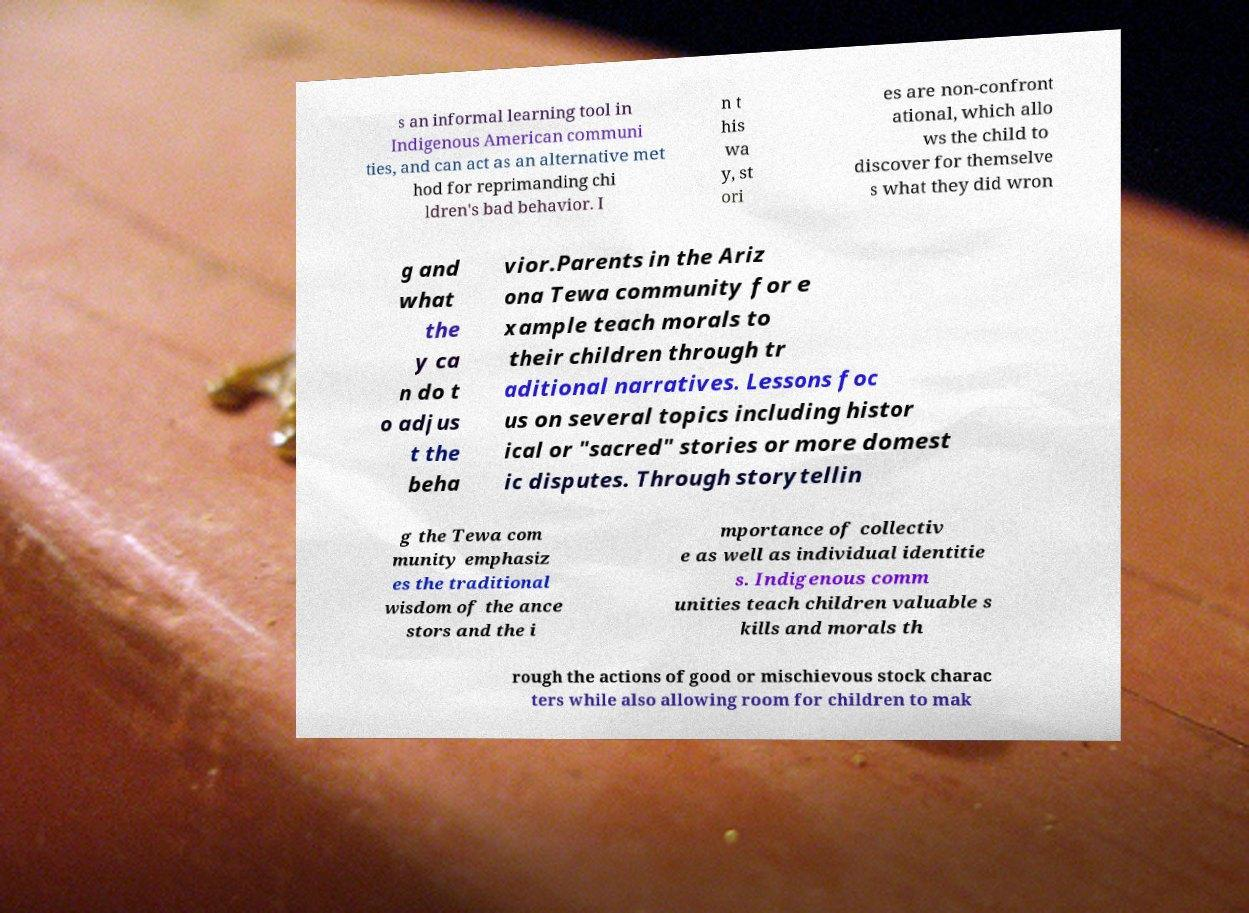Could you extract and type out the text from this image? s an informal learning tool in Indigenous American communi ties, and can act as an alternative met hod for reprimanding chi ldren's bad behavior. I n t his wa y, st ori es are non-confront ational, which allo ws the child to discover for themselve s what they did wron g and what the y ca n do t o adjus t the beha vior.Parents in the Ariz ona Tewa community for e xample teach morals to their children through tr aditional narratives. Lessons foc us on several topics including histor ical or "sacred" stories or more domest ic disputes. Through storytellin g the Tewa com munity emphasiz es the traditional wisdom of the ance stors and the i mportance of collectiv e as well as individual identitie s. Indigenous comm unities teach children valuable s kills and morals th rough the actions of good or mischievous stock charac ters while also allowing room for children to mak 